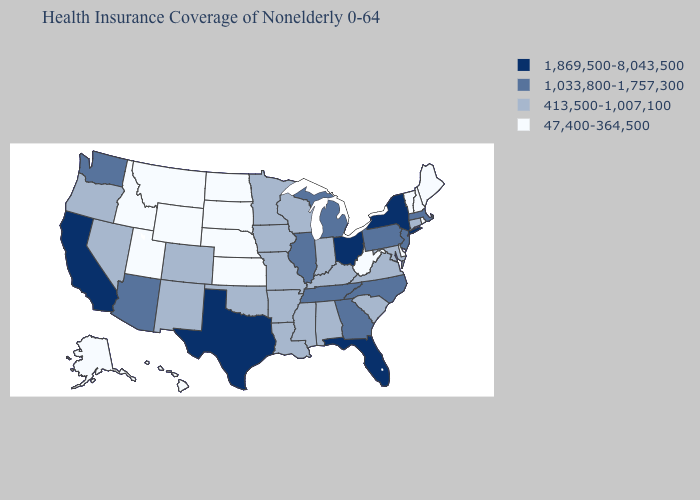Among the states that border New York , does Connecticut have the highest value?
Write a very short answer. No. Among the states that border Delaware , which have the highest value?
Be succinct. New Jersey, Pennsylvania. What is the lowest value in the USA?
Quick response, please. 47,400-364,500. What is the highest value in the MidWest ?
Short answer required. 1,869,500-8,043,500. Which states hav the highest value in the West?
Short answer required. California. What is the lowest value in the MidWest?
Answer briefly. 47,400-364,500. Does Illinois have a lower value than Ohio?
Short answer required. Yes. Name the states that have a value in the range 413,500-1,007,100?
Answer briefly. Alabama, Arkansas, Colorado, Connecticut, Indiana, Iowa, Kentucky, Louisiana, Maryland, Minnesota, Mississippi, Missouri, Nevada, New Mexico, Oklahoma, Oregon, South Carolina, Virginia, Wisconsin. Name the states that have a value in the range 47,400-364,500?
Answer briefly. Alaska, Delaware, Hawaii, Idaho, Kansas, Maine, Montana, Nebraska, New Hampshire, North Dakota, Rhode Island, South Dakota, Utah, Vermont, West Virginia, Wyoming. Name the states that have a value in the range 1,869,500-8,043,500?
Concise answer only. California, Florida, New York, Ohio, Texas. Does Wyoming have a higher value than South Carolina?
Concise answer only. No. Among the states that border Kansas , does Colorado have the highest value?
Write a very short answer. Yes. Name the states that have a value in the range 1,033,800-1,757,300?
Keep it brief. Arizona, Georgia, Illinois, Massachusetts, Michigan, New Jersey, North Carolina, Pennsylvania, Tennessee, Washington. What is the value of New Jersey?
Short answer required. 1,033,800-1,757,300. Among the states that border Kansas , which have the lowest value?
Short answer required. Nebraska. 